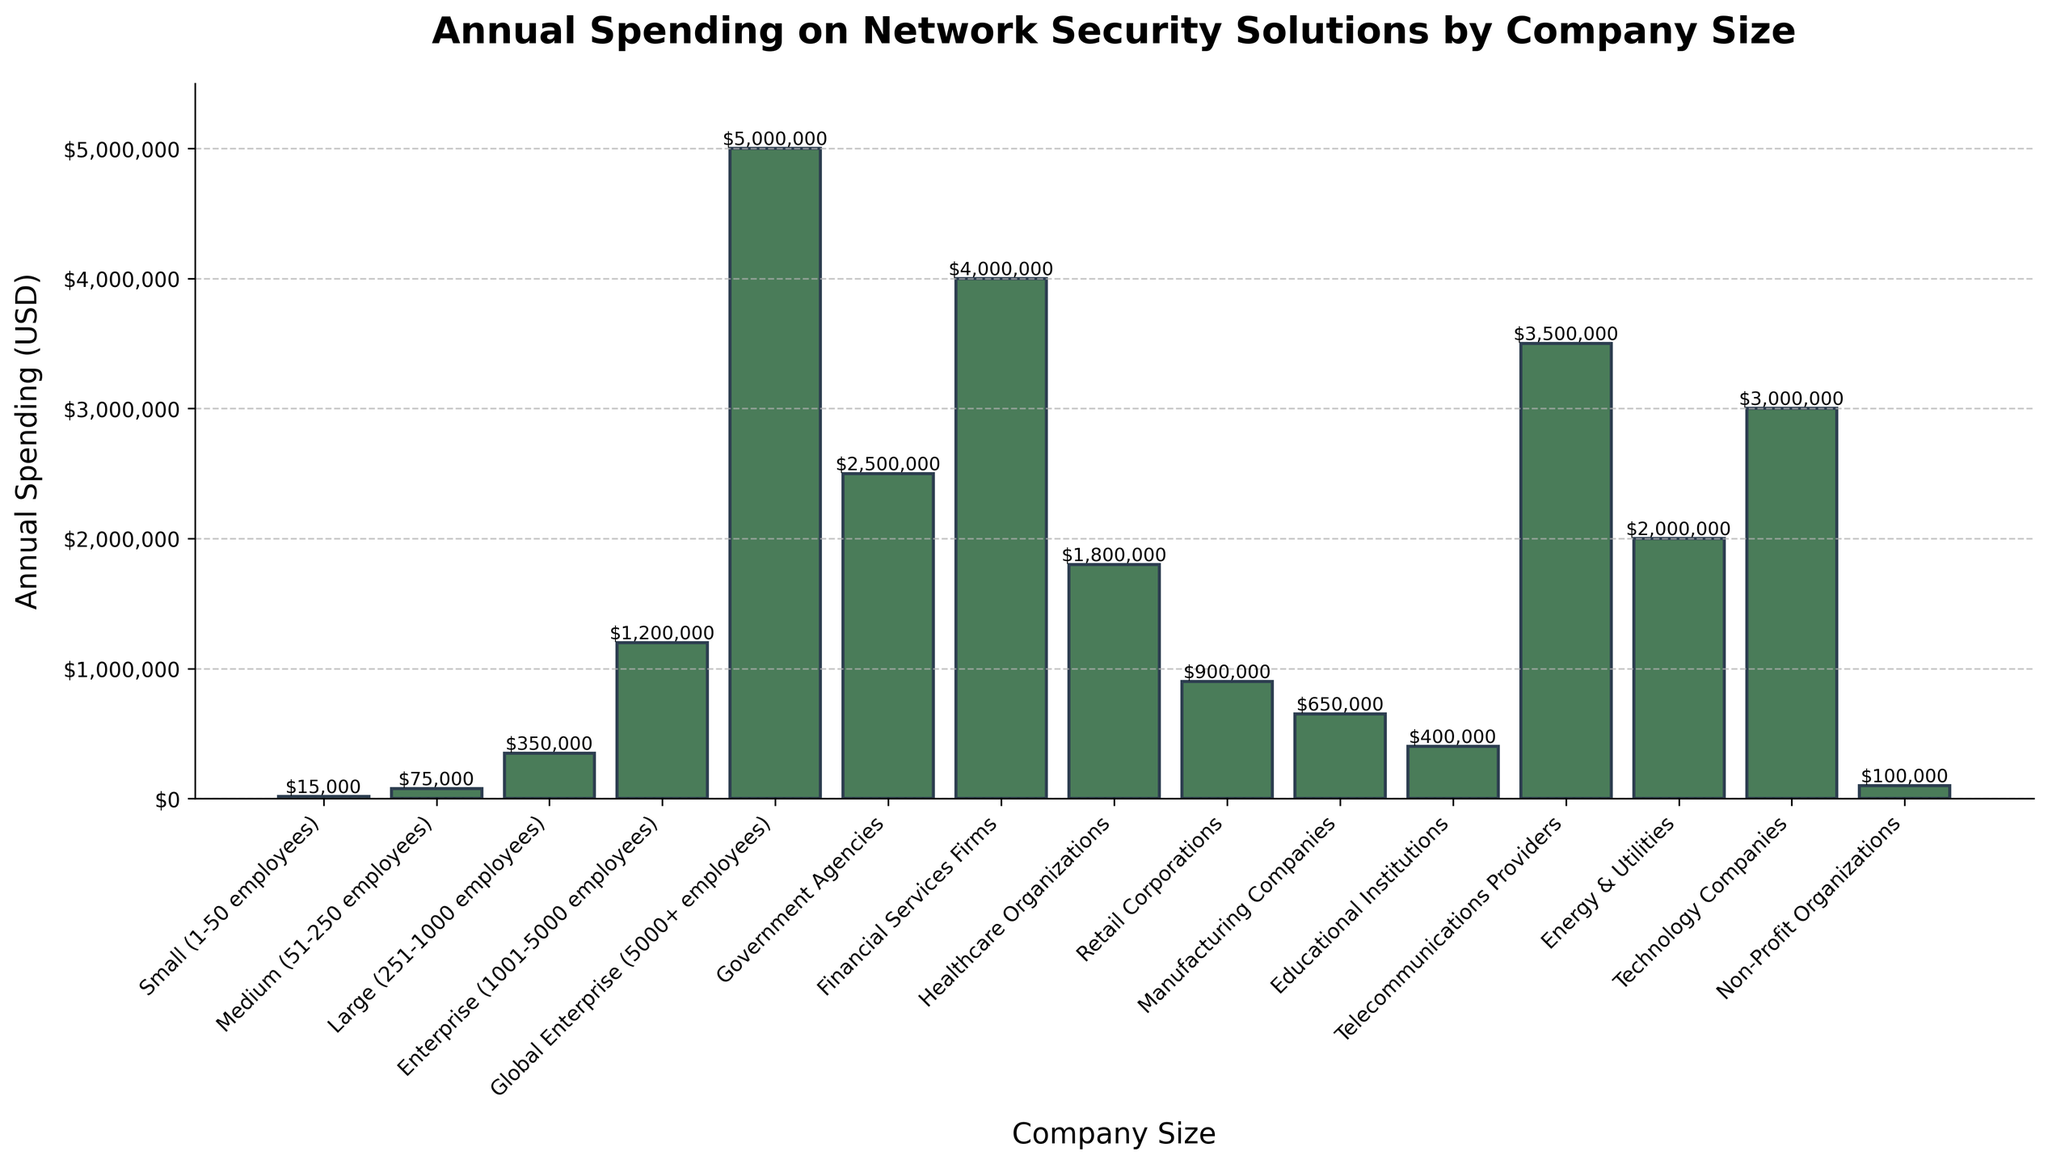what is the highest annual spending on network security solutions? The figure shows bars representing annual spending for different company sizes. The highest bar corresponds to 'Global Enterprise (5000+ employees)' with spending of $5,000,000.
Answer: $5,000,000 Which company size has the second-lowest annual spending? By examining the height of the bars, 'Non-Profit Organizations' has the lowest annual spending of $100,000, and 'Small (1-50 employees)' has the second-lowest spending of $15,000.
Answer: Small (1-50 employees) How much more do Financial Services Firms spend compared to Manufacturing Companies? The bar for Financial Services Firms shows $4,000,000, and the bar for Manufacturing Companies shows $650,000. The difference is $4,000,000 - $650,000.
Answer: $3,350,000 What is the combined annual spending of Enterprise, Government Agencies, and Telecommunications Providers? The figure shows annual spending of $1,200,000 for Enterprise, $2,500,000 for Government Agencies, and $3,500,000 for Telecommunications Providers. The sum is $1,200,000 + $2,500,000 + $3,500,000.
Answer: $7,200,000 Which company size has an annual spending closest to $1,000,000? By comparing the heights of the bars, 'Retail Corporations' has an annual spending of $900,000, which is closest to $1,000,000.
Answer: Retail Corporations Is the annual spending of Healthcare Organizations greater than that of Educational Institutions and Energy & Utilities combined? Healthcare Organizations have an annual spending of $1,800,000. Educational Institutions and Energy & Utilities combined have $400,000 + $2,000,000 = $2,400,000. $1,800,000 is less than $2,400,000.
Answer: No What is the median annual spending among all company sizes? The spending values listed in ascending order are: $100,000, $15,000, $150,000, $400,000, $650,000, $750,000, $900,000, $1,200,000, $1,500,000, $1,800,000, $2,000,000, $2,500,000, $3,000,000, $3,500,000, $4,000,000, $5,000,000. The median is the middle value, so for 16 data points, it is the average of the 8th and 9th values ($1,200,000 and $1,500,000).
Answer: $1,350,000 What is the approximate difference in spending between the largest and the smallest company sizes? The largest company size ('Global Enterprise (5000+ employees)') spends $5,000,000, and the smallest company size ('Non-Profit Organizations') spends $100,000. The difference is $5,000,000 - $100,000.
Answer: $4,900,000 